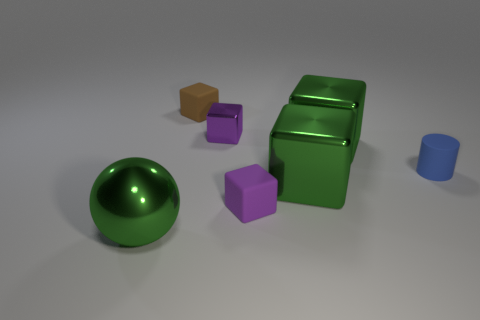Is there anything else that has the same size as the brown rubber cube?
Give a very brief answer. Yes. There is a purple matte thing; is it the same shape as the object that is on the left side of the tiny brown cube?
Make the answer very short. No. There is a small matte thing that is in front of the tiny matte object to the right of the matte cube in front of the tiny blue matte object; what is its color?
Provide a short and direct response. Purple. What number of objects are metal objects on the right side of the sphere or small blocks right of the tiny purple shiny thing?
Provide a short and direct response. 4. What number of other objects are there of the same color as the tiny matte cylinder?
Give a very brief answer. 0. There is a large green metal thing that is on the left side of the tiny brown block; does it have the same shape as the tiny brown thing?
Offer a very short reply. No. Are there fewer purple matte blocks on the left side of the small matte cylinder than tiny rubber cubes?
Your answer should be compact. Yes. Is there a small brown object made of the same material as the tiny cylinder?
Your answer should be very brief. Yes. There is a brown block that is the same size as the blue matte thing; what is it made of?
Provide a short and direct response. Rubber. Are there fewer big green blocks to the left of the tiny brown matte thing than small purple blocks that are on the right side of the purple metallic object?
Offer a terse response. Yes. 